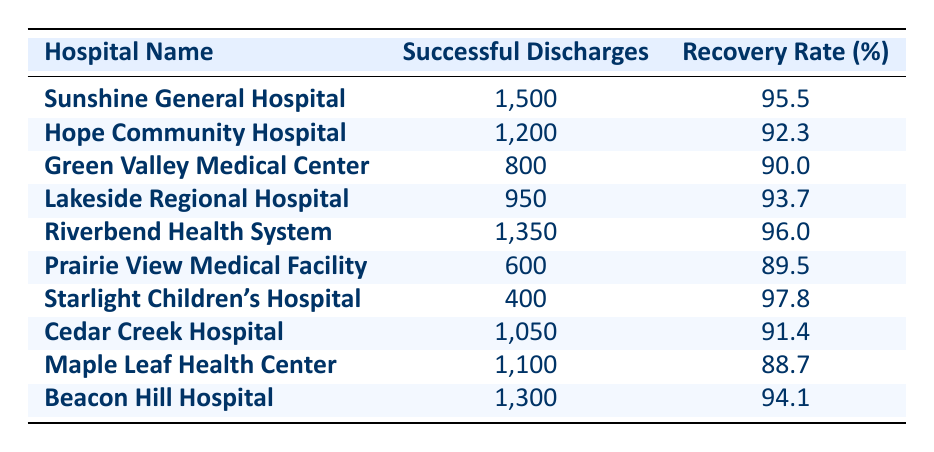What is the highest patient recovery rate among the hospitals listed? Looking at the recovery rates in the table, the highest value is 97.8%, which belongs to Starlight Children's Hospital.
Answer: 97.8% Which hospital had the lowest number of successful discharge cases? By examining the column for successful discharge cases, the lowest number is 400 from Starlight Children's Hospital.
Answer: 400 What is the total number of successful discharge cases from all hospitals? To find the total, we sum the successful discharge cases: 1500 + 1200 + 800 + 950 + 1350 + 600 + 400 + 1050 + 1100 + 1300 = 10000.
Answer: 10000 Is the patient recovery rate of Green Valley Medical Center above 90%? The recovery rate for Green Valley Medical Center is 90.0%, which is equal to but not above 90%. Therefore, the statement is false.
Answer: No What is the average patient recovery rate across all hospitals? The average is calculated by summing the recovery rates (95.5 + 92.3 + 90.0 + 93.7 + 96.0 + 89.5 + 97.8 + 91.4 + 88.7 + 94.1 = 919.0) and dividing by the number of hospitals (10). So, 919.0 / 10 = 91.9.
Answer: 91.9 Which hospital has a higher recovery rate: Riverbend Health System or Beacon Hill Hospital? Riverbend Health System has a recovery rate of 96.0%, while Beacon Hill Hospital has a rate of 94.1%. Since 96.0% is greater than 94.1%, Riverbend Health System has the higher recovery rate.
Answer: Riverbend Health System How many hospitals achieved a successful discharge of over 1000 cases? From the table, the hospitals with over 1000 successful discharges are Sunshine General Hospital, Riverbend Health System, Cedar Creek Hospital, Maple Leaf Health Center, and Beacon Hill Hospital, totaling 5 hospitals.
Answer: 5 Is the recovery rate of Hope Community Hospital greater than the recovery rate of Lakeside Regional Hospital? Hope Community Hospital has a recovery rate of 92.3%, while Lakeside Regional Hospital has a rate of 93.7%. Since 92.3% is less than 93.7%, the statement is false.
Answer: No 